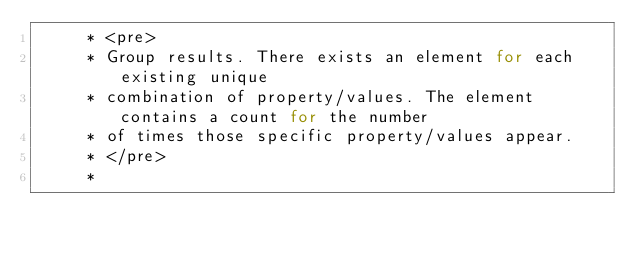<code> <loc_0><loc_0><loc_500><loc_500><_Java_>     * <pre>
     * Group results. There exists an element for each existing unique
     * combination of property/values. The element contains a count for the number
     * of times those specific property/values appear.
     * </pre>
     *</code> 